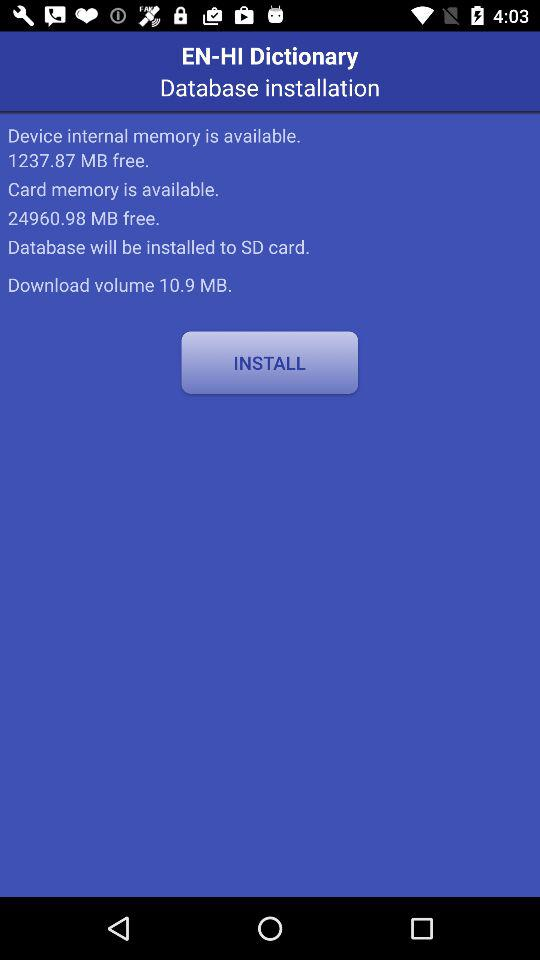How much "Device internal memory" is available? The available memory is 1237.87 MB free. 